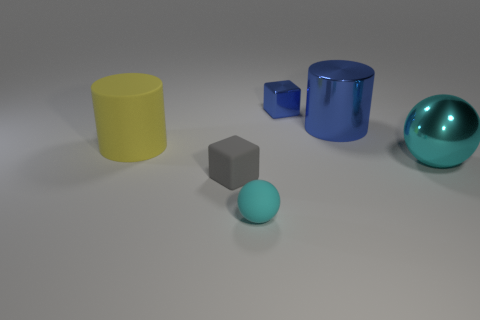What number of other objects are there of the same size as the cyan metal object?
Your answer should be compact. 2. How many large cyan metal spheres are there?
Make the answer very short. 1. Is there anything else that has the same shape as the tiny gray object?
Your response must be concise. Yes. Do the cylinder that is on the left side of the tiny rubber ball and the block that is in front of the big yellow matte cylinder have the same material?
Offer a very short reply. Yes. What material is the gray block?
Keep it short and to the point. Rubber. What number of big green things have the same material as the tiny blue block?
Make the answer very short. 0. How many shiny things are either purple spheres or cyan balls?
Keep it short and to the point. 1. There is a metal object that is behind the blue metallic cylinder; is it the same shape as the metallic object that is right of the large blue metallic cylinder?
Give a very brief answer. No. There is a object that is behind the big cyan metallic sphere and right of the tiny blue metal object; what is its color?
Ensure brevity in your answer.  Blue. There is a cyan ball in front of the large metal ball; does it have the same size as the cylinder in front of the large blue thing?
Keep it short and to the point. No. 